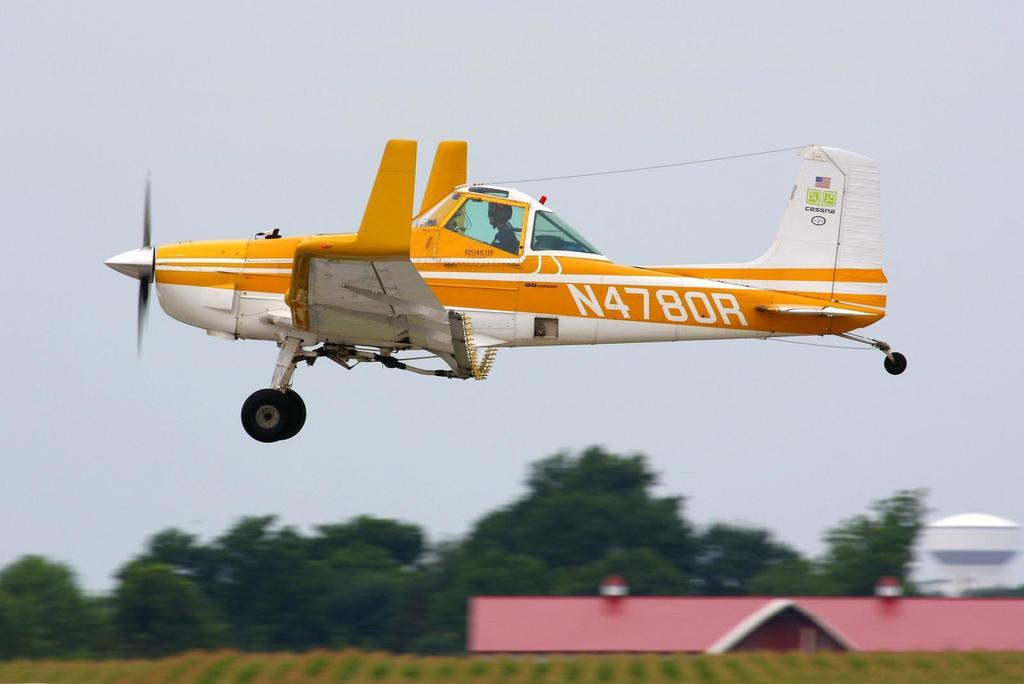<image>
Present a compact description of the photo's key features. A yellow and white airplane has N4780R on the side of it. 